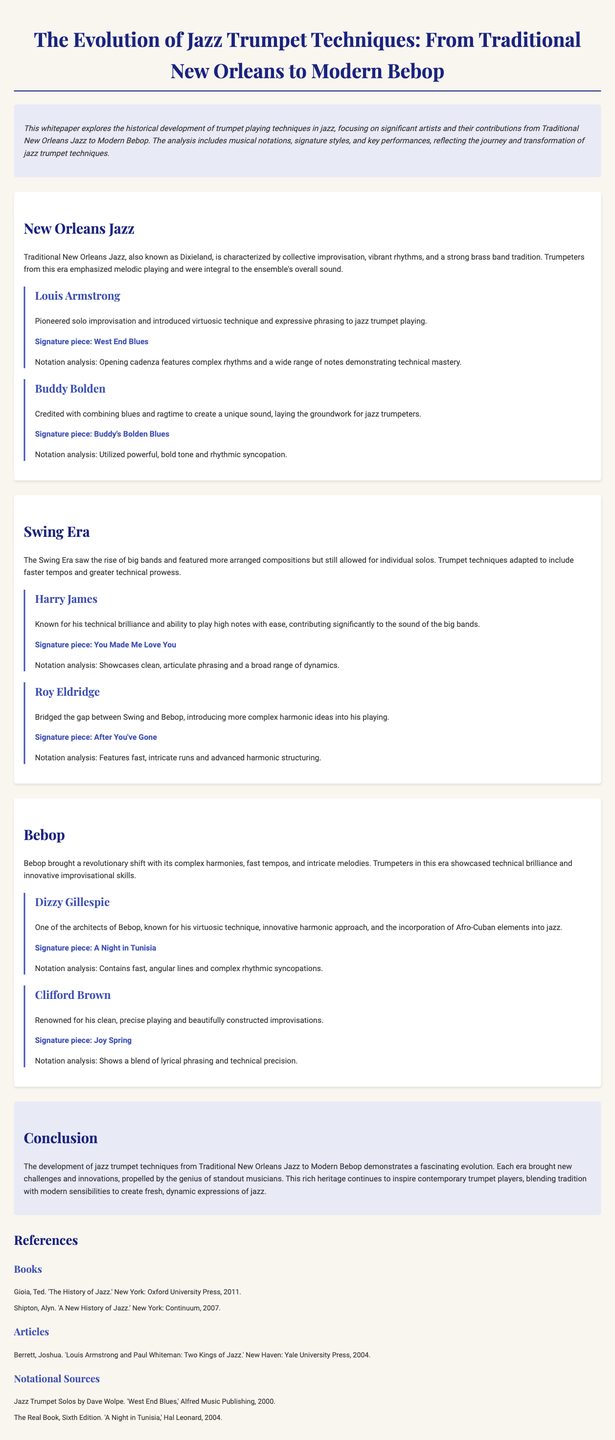What is the title of the whitepaper? The title is the main heading presented at the top of the document.
Answer: The Evolution of Jazz Trumpet Techniques: From Traditional New Orleans to Modern Bebop Who is credited with pioneering solo improvisation in jazz trumpet? The document mentions Louis Armstrong as a significant figure in this area.
Answer: Louis Armstrong What is the signature piece of Dizzy Gillespie? The signature piece is highlighted in the section about Bebop artists.
Answer: A Night in Tunisia Which musical era did Harry James contribute to? The document specifies the Swing Era as the period in which he was influential.
Answer: Swing Era What type of jazz is characterized by collective improvisation? This term refers to the main stylistic approach of the New Orleans jazz era as described.
Answer: Traditional New Orleans Jazz What significant contribution did Roy Eldridge make to jazz trumpet playing? The text describes his influence on harmonic complexity between different eras of jazz.
Answer: Complex harmonic ideas How many notable artists are mentioned in the New Orleans Jazz section? The document lists artists in each section, specifically in the New Orleans era.
Answer: Two What analysis is provided for the piece 'West End Blues'? The analysis includes observations on rhythms and note ranges used by the artist.
Answer: Complex rhythms and a wide range of notes What visual element is used to highlight important sections in the document? The document describes style elements used for sections and artists to enhance readability.
Answer: Background color and border styles 